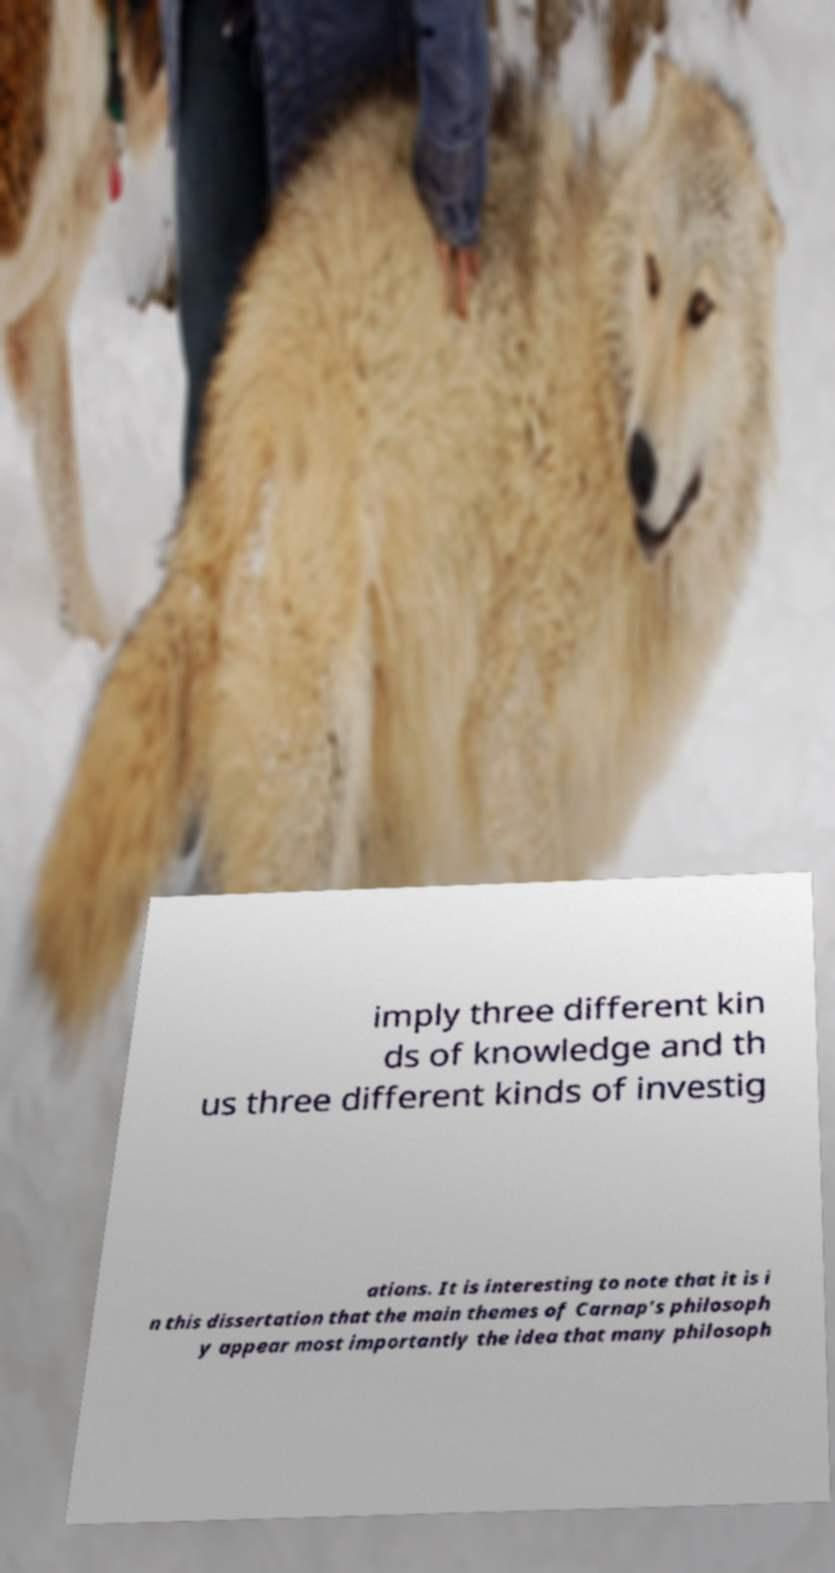There's text embedded in this image that I need extracted. Can you transcribe it verbatim? imply three different kin ds of knowledge and th us three different kinds of investig ations. It is interesting to note that it is i n this dissertation that the main themes of Carnap's philosoph y appear most importantly the idea that many philosoph 